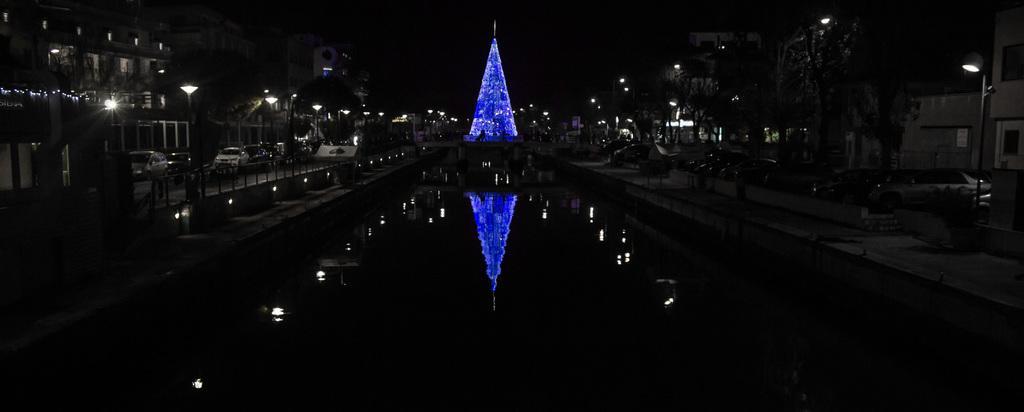In one or two sentences, can you explain what this image depicts? There is water. On the sides there are trees, buildings and light poles. In the back there is a tower with lights. On the water there are reflections of tower and lights. 